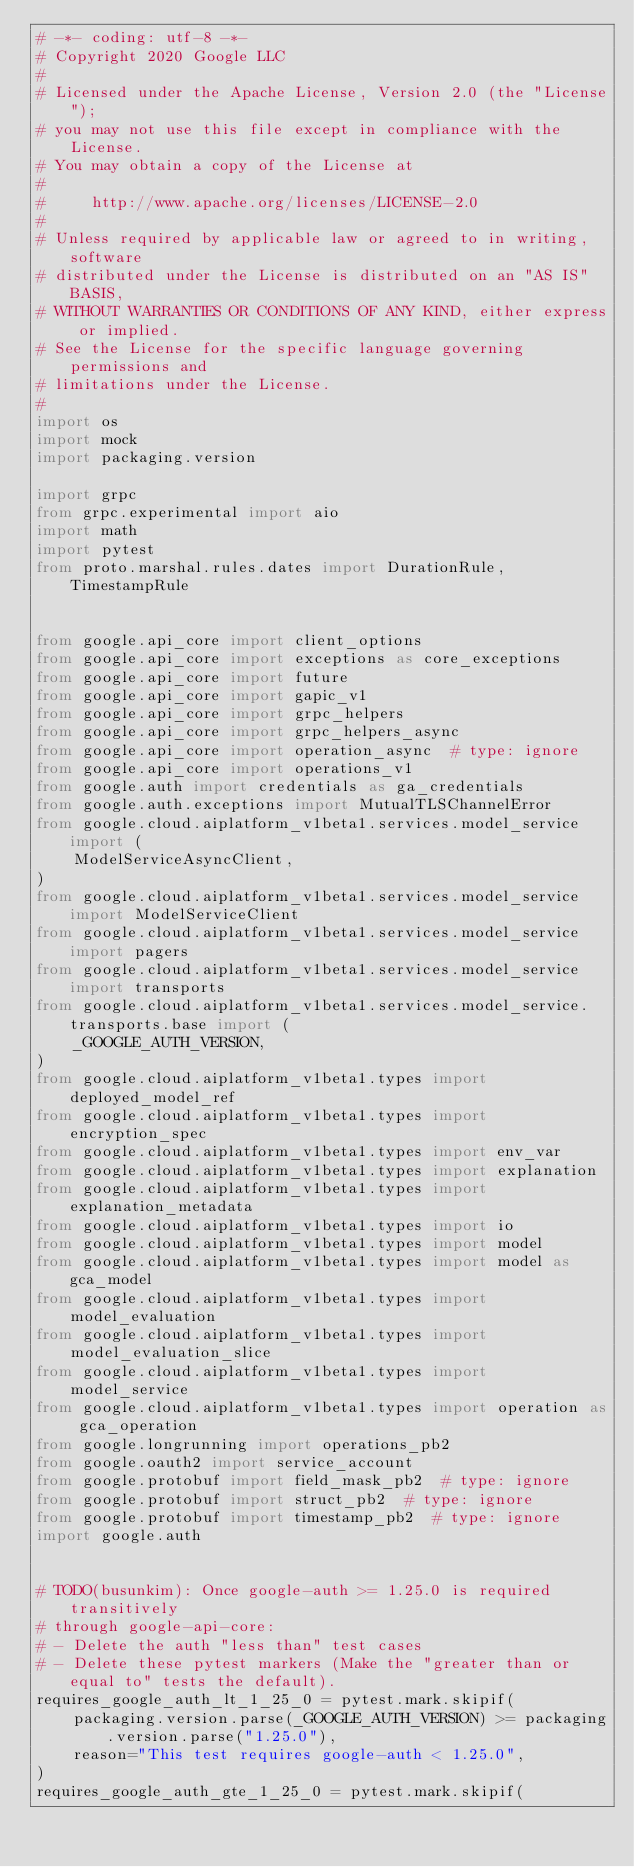<code> <loc_0><loc_0><loc_500><loc_500><_Python_># -*- coding: utf-8 -*-
# Copyright 2020 Google LLC
#
# Licensed under the Apache License, Version 2.0 (the "License");
# you may not use this file except in compliance with the License.
# You may obtain a copy of the License at
#
#     http://www.apache.org/licenses/LICENSE-2.0
#
# Unless required by applicable law or agreed to in writing, software
# distributed under the License is distributed on an "AS IS" BASIS,
# WITHOUT WARRANTIES OR CONDITIONS OF ANY KIND, either express or implied.
# See the License for the specific language governing permissions and
# limitations under the License.
#
import os
import mock
import packaging.version

import grpc
from grpc.experimental import aio
import math
import pytest
from proto.marshal.rules.dates import DurationRule, TimestampRule


from google.api_core import client_options
from google.api_core import exceptions as core_exceptions
from google.api_core import future
from google.api_core import gapic_v1
from google.api_core import grpc_helpers
from google.api_core import grpc_helpers_async
from google.api_core import operation_async  # type: ignore
from google.api_core import operations_v1
from google.auth import credentials as ga_credentials
from google.auth.exceptions import MutualTLSChannelError
from google.cloud.aiplatform_v1beta1.services.model_service import (
    ModelServiceAsyncClient,
)
from google.cloud.aiplatform_v1beta1.services.model_service import ModelServiceClient
from google.cloud.aiplatform_v1beta1.services.model_service import pagers
from google.cloud.aiplatform_v1beta1.services.model_service import transports
from google.cloud.aiplatform_v1beta1.services.model_service.transports.base import (
    _GOOGLE_AUTH_VERSION,
)
from google.cloud.aiplatform_v1beta1.types import deployed_model_ref
from google.cloud.aiplatform_v1beta1.types import encryption_spec
from google.cloud.aiplatform_v1beta1.types import env_var
from google.cloud.aiplatform_v1beta1.types import explanation
from google.cloud.aiplatform_v1beta1.types import explanation_metadata
from google.cloud.aiplatform_v1beta1.types import io
from google.cloud.aiplatform_v1beta1.types import model
from google.cloud.aiplatform_v1beta1.types import model as gca_model
from google.cloud.aiplatform_v1beta1.types import model_evaluation
from google.cloud.aiplatform_v1beta1.types import model_evaluation_slice
from google.cloud.aiplatform_v1beta1.types import model_service
from google.cloud.aiplatform_v1beta1.types import operation as gca_operation
from google.longrunning import operations_pb2
from google.oauth2 import service_account
from google.protobuf import field_mask_pb2  # type: ignore
from google.protobuf import struct_pb2  # type: ignore
from google.protobuf import timestamp_pb2  # type: ignore
import google.auth


# TODO(busunkim): Once google-auth >= 1.25.0 is required transitively
# through google-api-core:
# - Delete the auth "less than" test cases
# - Delete these pytest markers (Make the "greater than or equal to" tests the default).
requires_google_auth_lt_1_25_0 = pytest.mark.skipif(
    packaging.version.parse(_GOOGLE_AUTH_VERSION) >= packaging.version.parse("1.25.0"),
    reason="This test requires google-auth < 1.25.0",
)
requires_google_auth_gte_1_25_0 = pytest.mark.skipif(</code> 